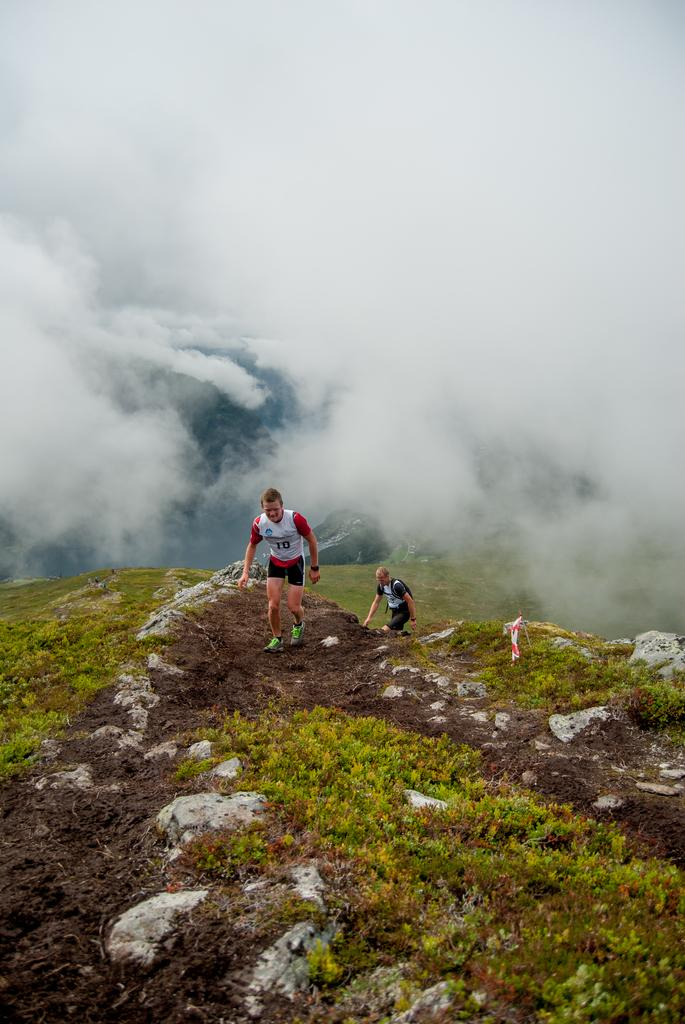What can be seen in the front of the image? There are people, grass, and rocks in the front of the image. What are the people in the image doing? The people are walking in the image. What is visible in the background of the image? There are clouds in the background of the image. What type of rhythm can be heard coming from the trucks in the image? There are no trucks present in the image, so it's not possible to determine what rhythm might be heard. Is there a hill visible in the image? There is no mention of a hill in the provided facts, so we cannot determine if one is present in the image. 